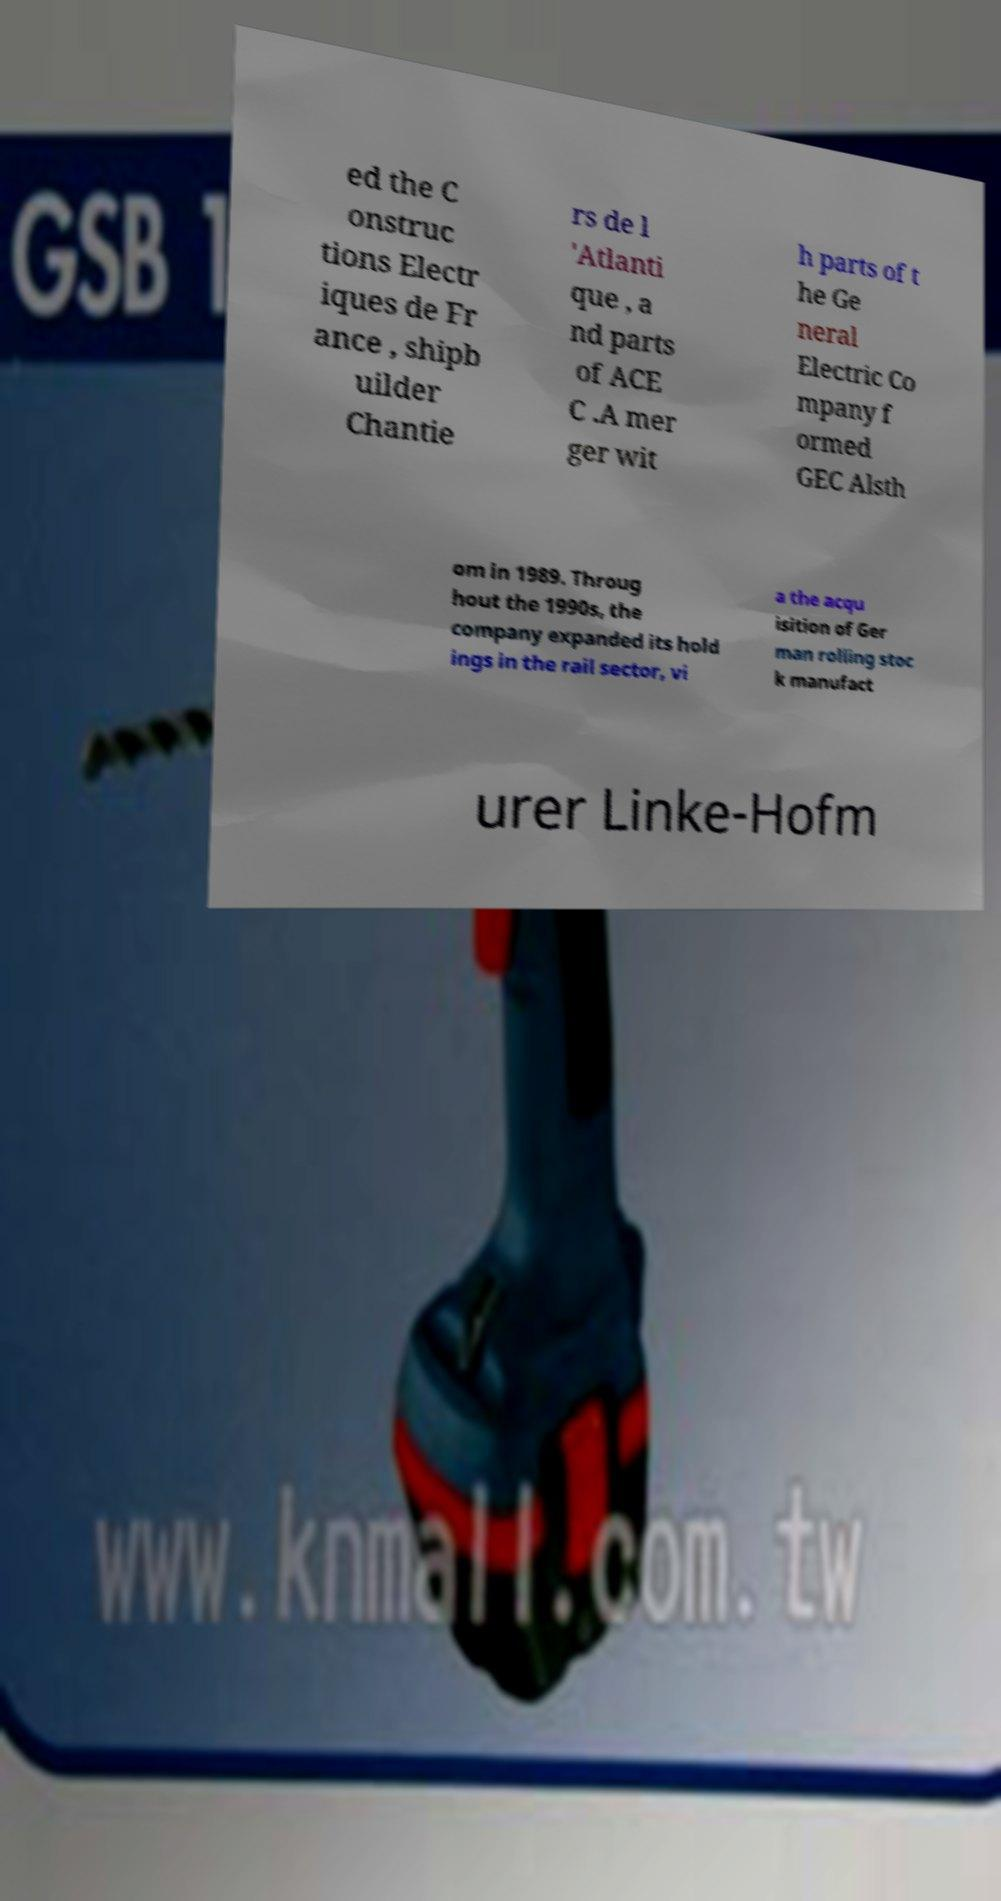For documentation purposes, I need the text within this image transcribed. Could you provide that? ed the C onstruc tions Electr iques de Fr ance , shipb uilder Chantie rs de l 'Atlanti que , a nd parts of ACE C .A mer ger wit h parts of t he Ge neral Electric Co mpany f ormed GEC Alsth om in 1989. Throug hout the 1990s, the company expanded its hold ings in the rail sector, vi a the acqu isition of Ger man rolling stoc k manufact urer Linke-Hofm 